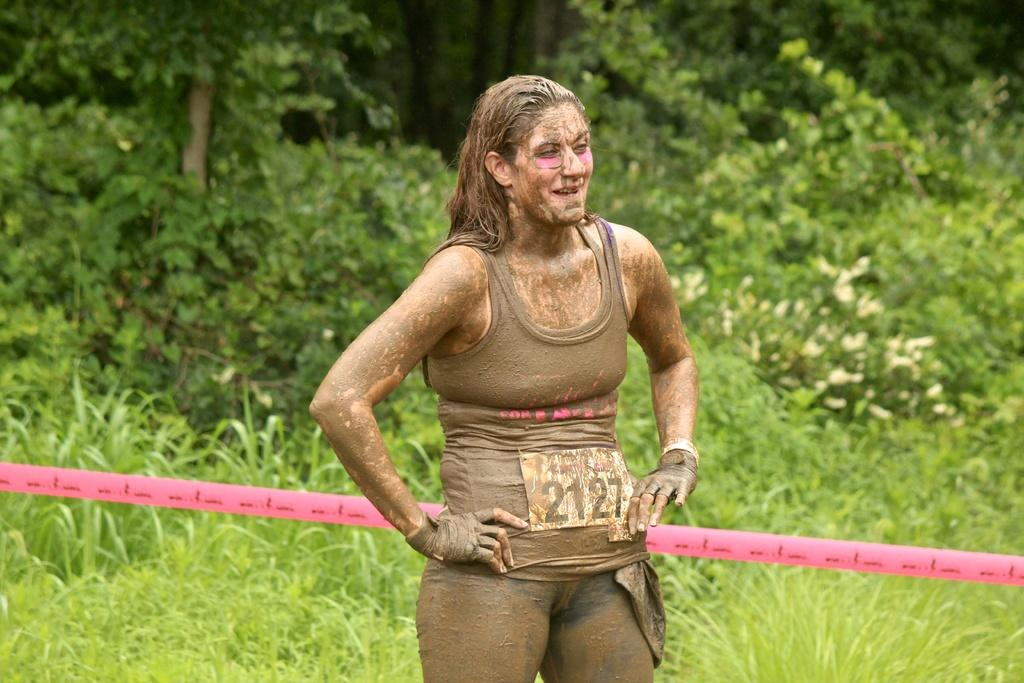Who is the main subject in the image? There is a woman standing in the center of the image. What can be seen in the background of the image? There are trees and plants in the background of the image. What object is located in the center of the image besides the woman? There is a tape in the center of the image. Is there any smoke coming from the woman's hand in the image? No, there is no smoke present in the image. 